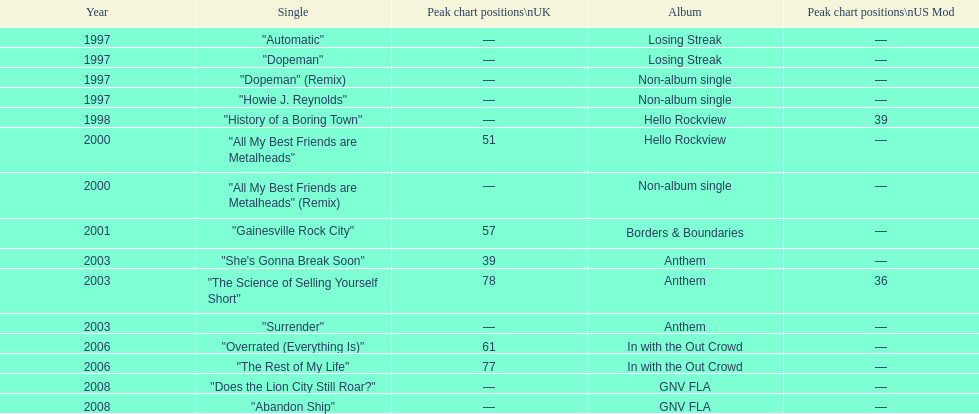What was the average chart position of their singles in the uk? 60.5. 